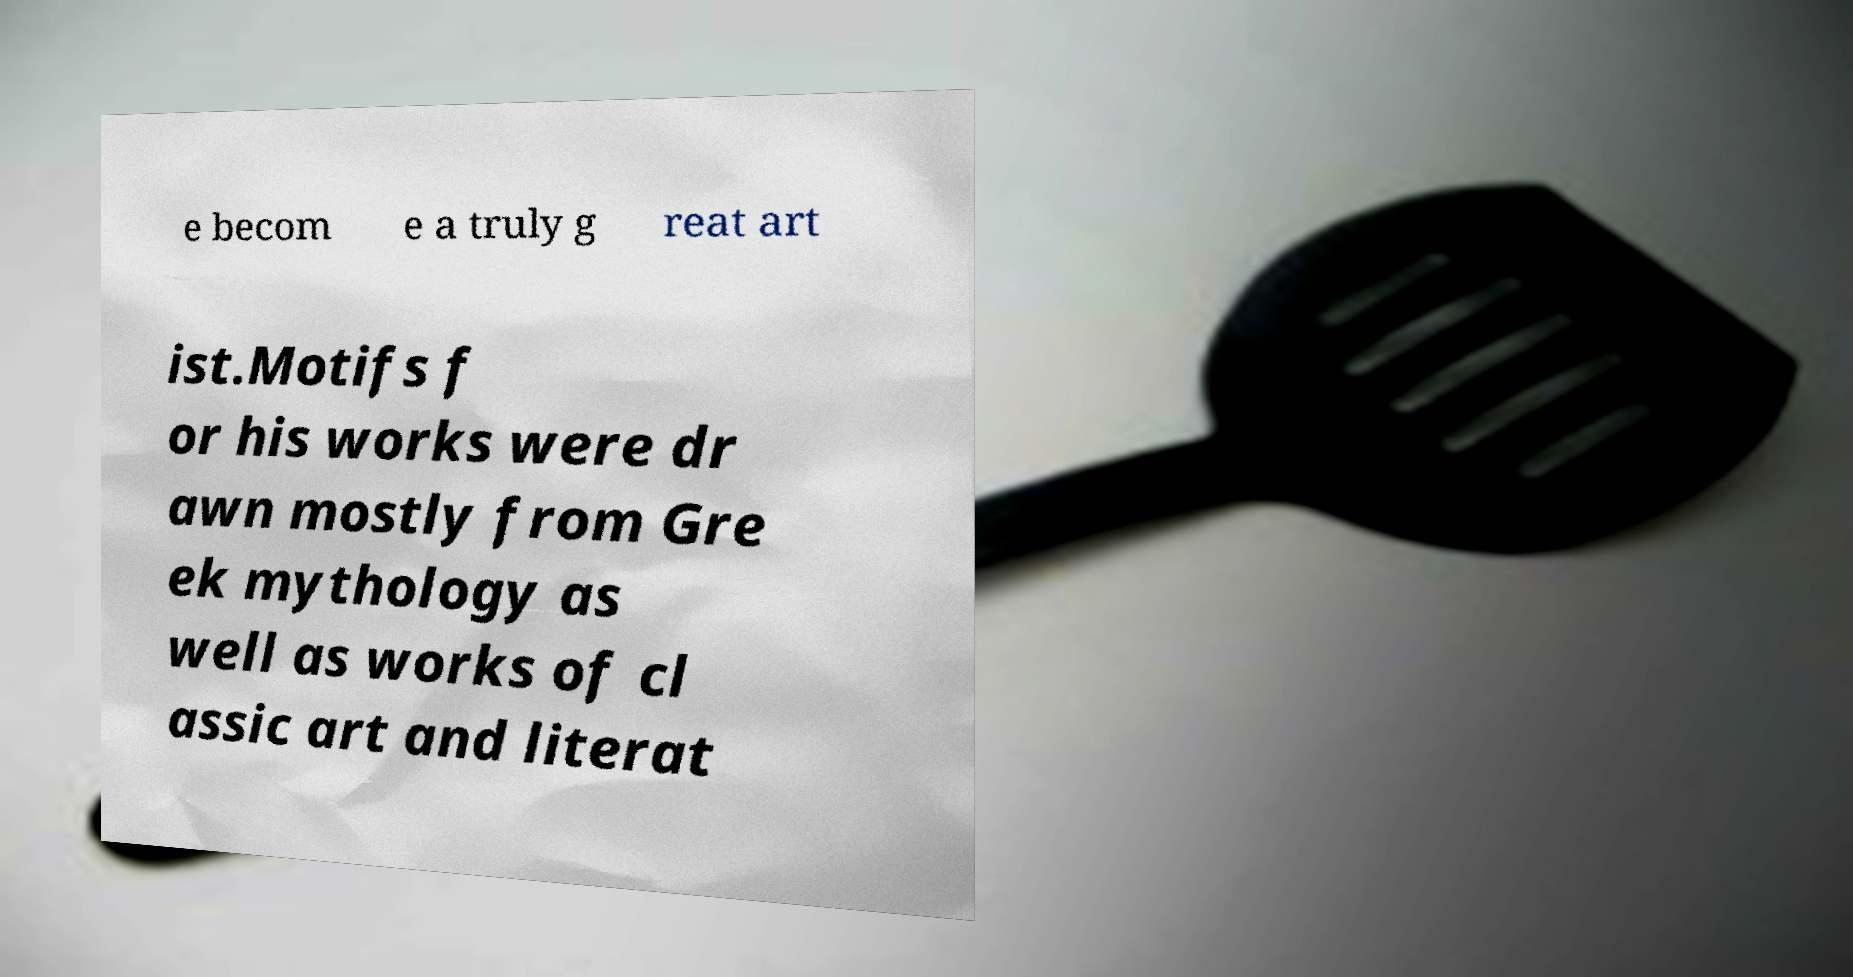Could you extract and type out the text from this image? e becom e a truly g reat art ist.Motifs f or his works were dr awn mostly from Gre ek mythology as well as works of cl assic art and literat 